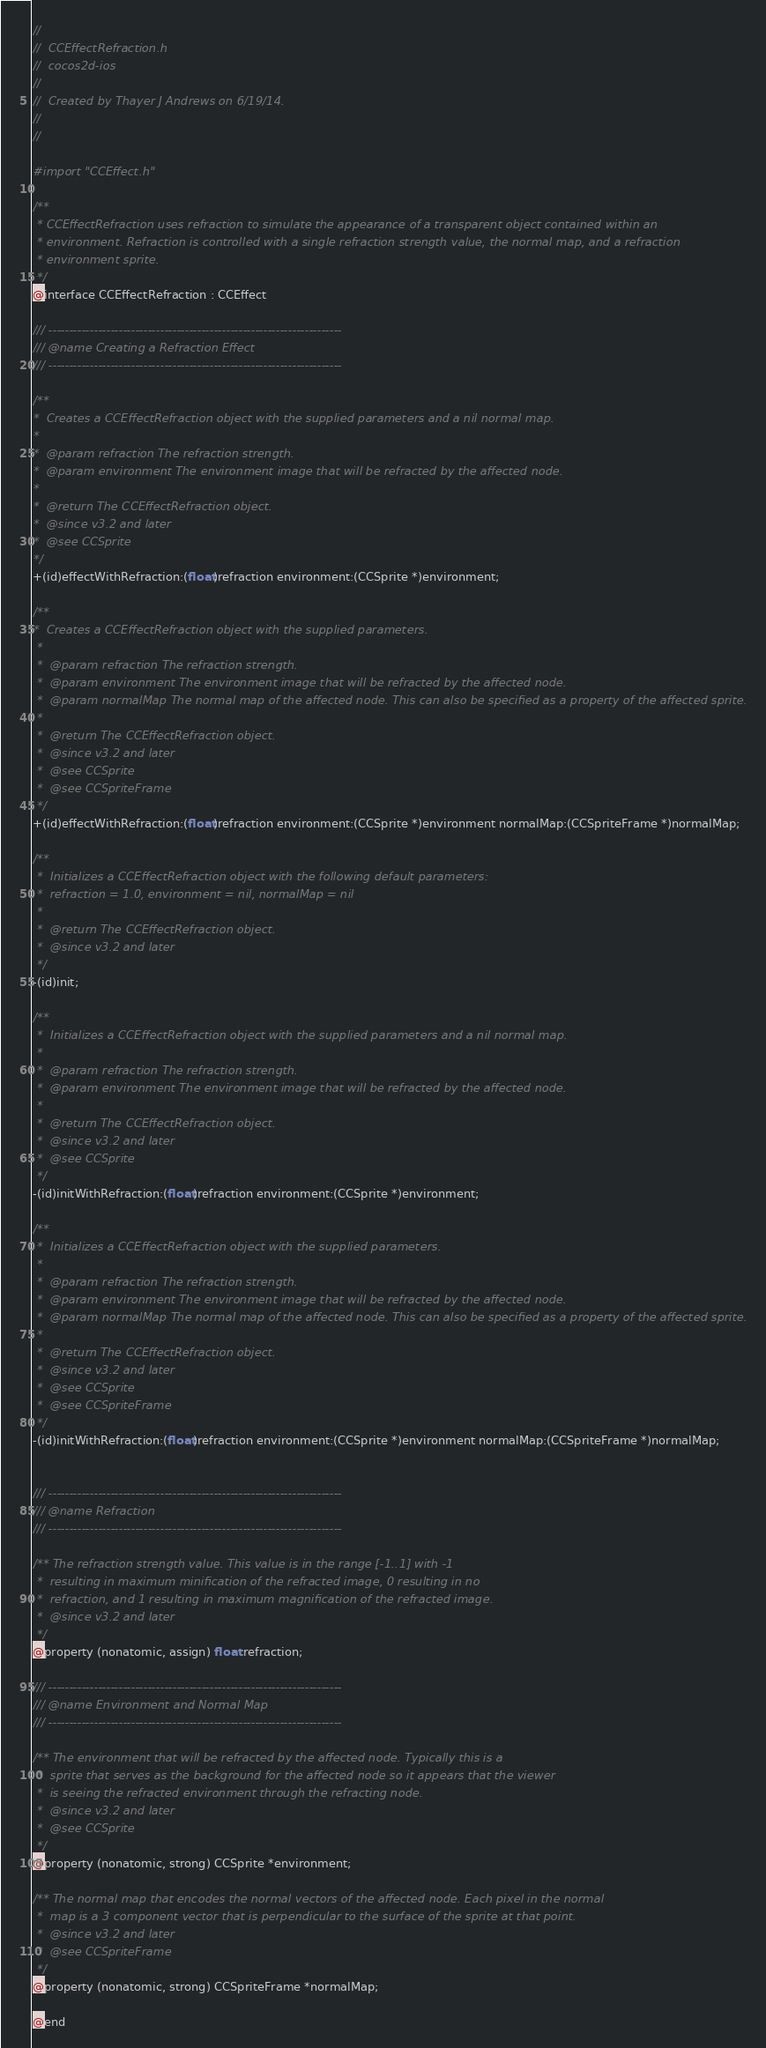Convert code to text. <code><loc_0><loc_0><loc_500><loc_500><_C_>//
//  CCEffectRefraction.h
//  cocos2d-ios
//
//  Created by Thayer J Andrews on 6/19/14.
//
//

#import "CCEffect.h"

/**
 * CCEffectRefraction uses refraction to simulate the appearance of a transparent object contained within an 
 * environment. Refraction is controlled with a single refraction strength value, the normal map, and a refraction 
 * environment sprite.
 */
@interface CCEffectRefraction : CCEffect

/// -----------------------------------------------------------------------
/// @name Creating a Refraction Effect
/// -----------------------------------------------------------------------

/**
*  Creates a CCEffectRefraction object with the supplied parameters and a nil normal map.
*
*  @param refraction The refraction strength.
*  @param environment The environment image that will be refracted by the affected node.
*
*  @return The CCEffectRefraction object.
*  @since v3.2 and later
*  @see CCSprite
*/
+(id)effectWithRefraction:(float)refraction environment:(CCSprite *)environment;

/**
*  Creates a CCEffectRefraction object with the supplied parameters.
 *
 *  @param refraction The refraction strength.
 *  @param environment The environment image that will be refracted by the affected node.
 *  @param normalMap The normal map of the affected node. This can also be specified as a property of the affected sprite.
 *
 *  @return The CCEffectRefraction object.
 *  @since v3.2 and later
 *  @see CCSprite
 *  @see CCSpriteFrame
 */
+(id)effectWithRefraction:(float)refraction environment:(CCSprite *)environment normalMap:(CCSpriteFrame *)normalMap;

/**
 *  Initializes a CCEffectRefraction object with the following default parameters:
 *  refraction = 1.0, environment = nil, normalMap = nil
 *
 *  @return The CCEffectRefraction object.
 *  @since v3.2 and later
 */
-(id)init;

/**
 *  Initializes a CCEffectRefraction object with the supplied parameters and a nil normal map.
 *
 *  @param refraction The refraction strength.
 *  @param environment The environment image that will be refracted by the affected node.
 *
 *  @return The CCEffectRefraction object.
 *  @since v3.2 and later
 *  @see CCSprite
 */
-(id)initWithRefraction:(float)refraction environment:(CCSprite *)environment;

/**
 *  Initializes a CCEffectRefraction object with the supplied parameters.
 *
 *  @param refraction The refraction strength.
 *  @param environment The environment image that will be refracted by the affected node.
 *  @param normalMap The normal map of the affected node. This can also be specified as a property of the affected sprite.
 *
 *  @return The CCEffectRefraction object.
 *  @since v3.2 and later
 *  @see CCSprite
 *  @see CCSpriteFrame
 */
-(id)initWithRefraction:(float)refraction environment:(CCSprite *)environment normalMap:(CCSpriteFrame *)normalMap;


/// -----------------------------------------------------------------------
/// @name Refraction
/// -----------------------------------------------------------------------

/** The refraction strength value. This value is in the range [-1..1] with -1
 *  resulting in maximum minification of the refracted image, 0 resulting in no
 *  refraction, and 1 resulting in maximum magnification of the refracted image.
 *  @since v3.2 and later
 */
@property (nonatomic, assign) float refraction;

/// -----------------------------------------------------------------------
/// @name Environment and Normal Map
/// -----------------------------------------------------------------------

/** The environment that will be refracted by the affected node. Typically this is a
 *  sprite that serves as the background for the affected node so it appears that the viewer
 *  is seeing the refracted environment through the refracting node.
 *  @since v3.2 and later
 *  @see CCSprite
 */
@property (nonatomic, strong) CCSprite *environment;

/** The normal map that encodes the normal vectors of the affected node. Each pixel in the normal
 *  map is a 3 component vector that is perpendicular to the surface of the sprite at that point.
 *  @since v3.2 and later
 *  @see CCSpriteFrame
 */
@property (nonatomic, strong) CCSpriteFrame *normalMap;

@end
</code> 